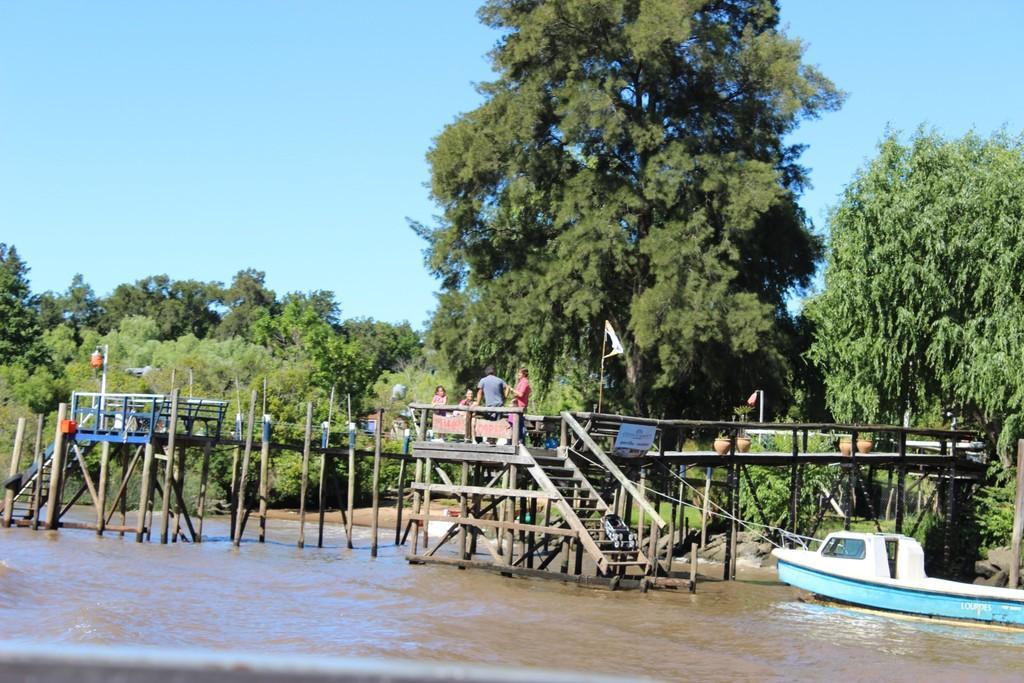Describe this image in one or two sentences. In the center of the image there is a wooden bridge on which two people are sitting and two people are standing. At the background of the image there are trees. There is ship in the image. At the bottom of the image there is water. At the top of the image there is sky. 